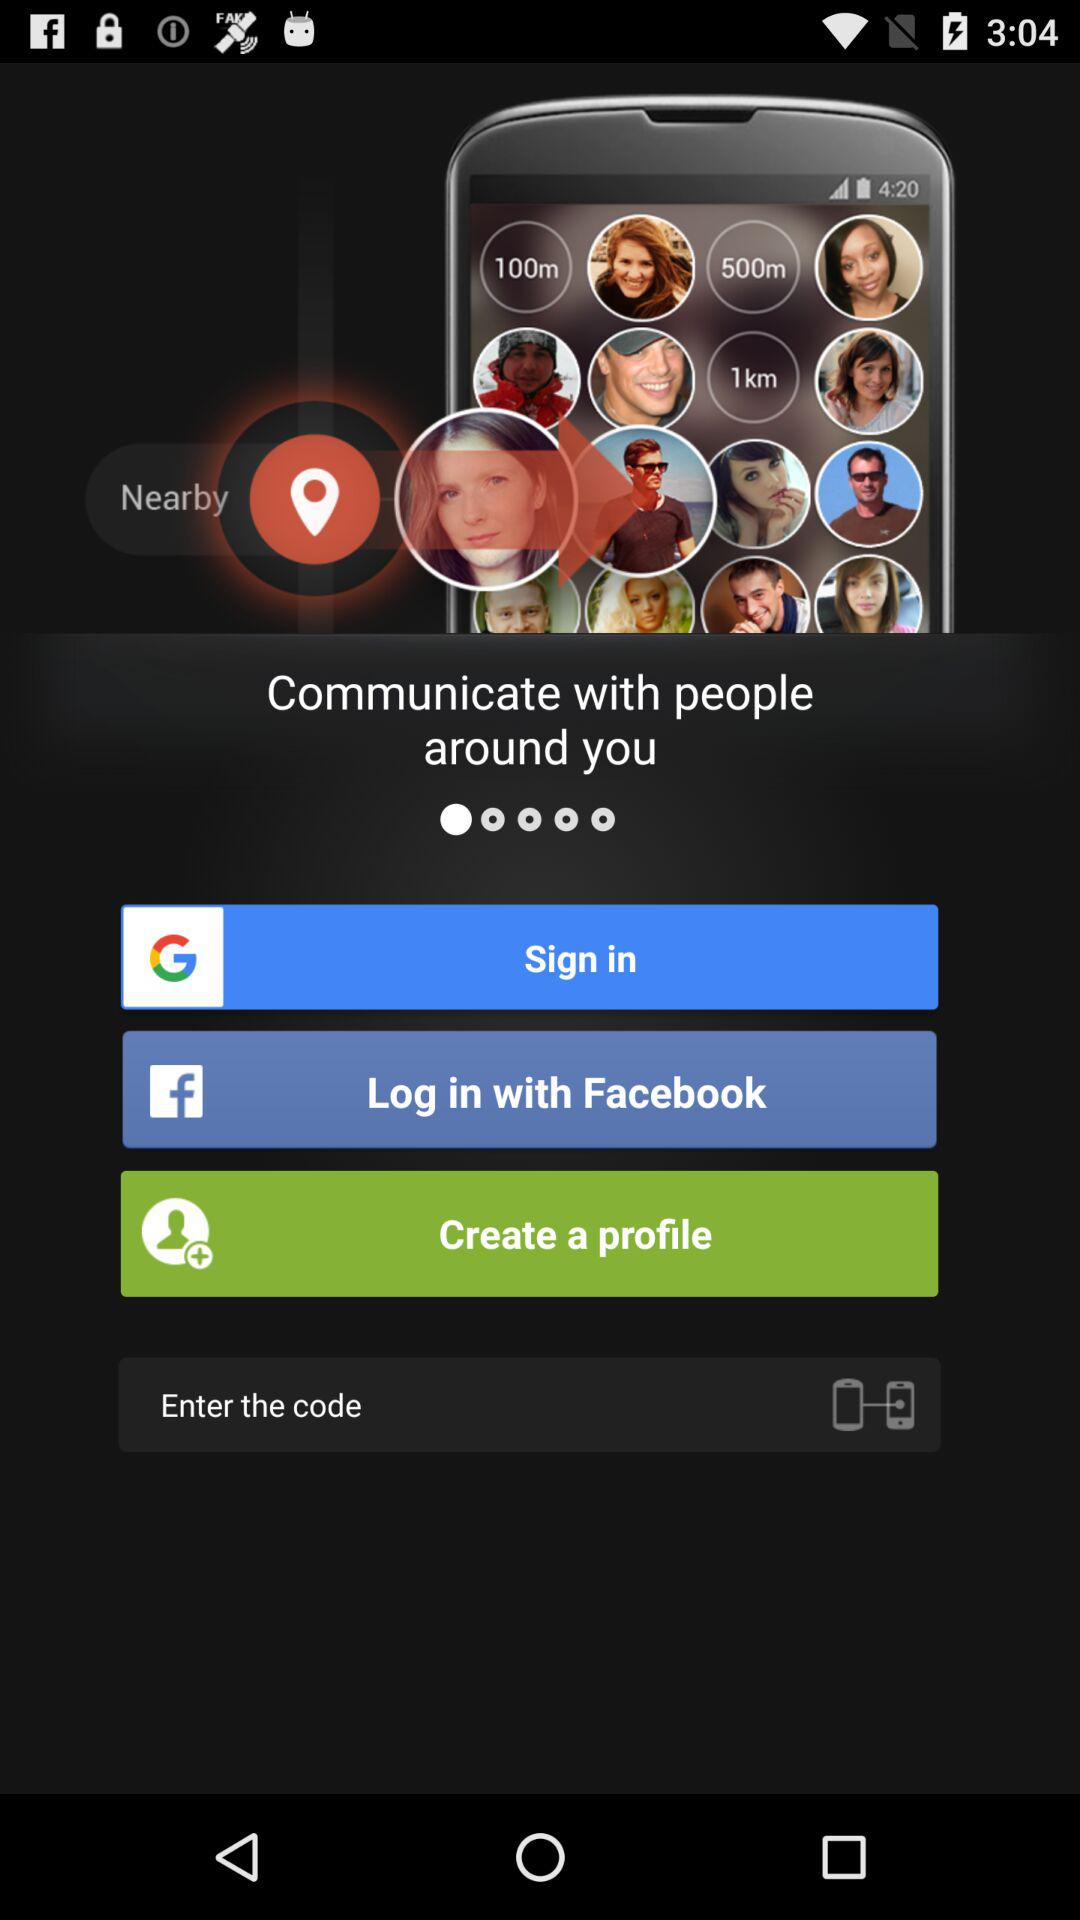Which are the different log-in options? The different log-in options are "Google" and "Facebook". 